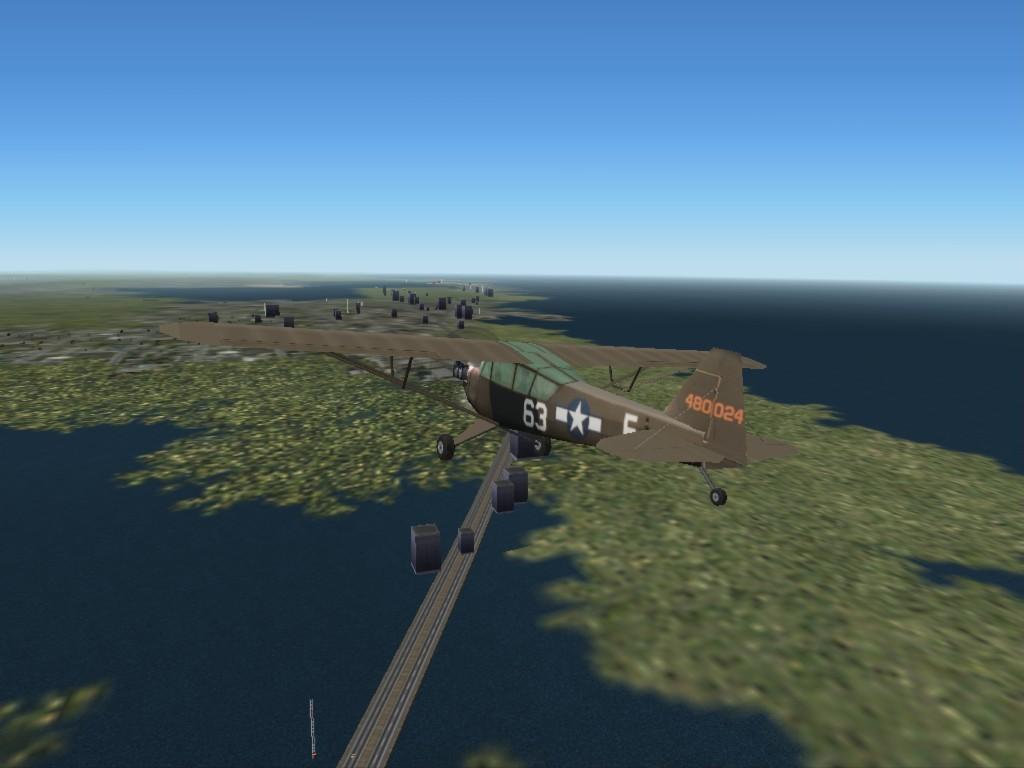What's the number written on the plane?
Give a very brief answer. 63. 